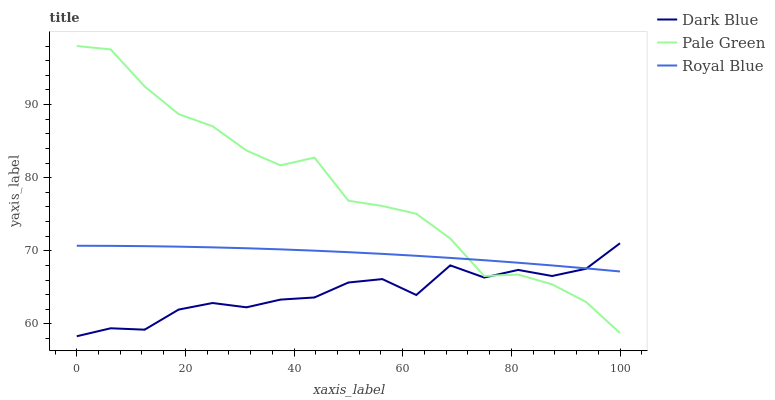Does Dark Blue have the minimum area under the curve?
Answer yes or no. Yes. Does Pale Green have the maximum area under the curve?
Answer yes or no. Yes. Does Royal Blue have the minimum area under the curve?
Answer yes or no. No. Does Royal Blue have the maximum area under the curve?
Answer yes or no. No. Is Royal Blue the smoothest?
Answer yes or no. Yes. Is Pale Green the roughest?
Answer yes or no. Yes. Is Pale Green the smoothest?
Answer yes or no. No. Is Royal Blue the roughest?
Answer yes or no. No. Does Dark Blue have the lowest value?
Answer yes or no. Yes. Does Pale Green have the lowest value?
Answer yes or no. No. Does Pale Green have the highest value?
Answer yes or no. Yes. Does Royal Blue have the highest value?
Answer yes or no. No. Does Royal Blue intersect Pale Green?
Answer yes or no. Yes. Is Royal Blue less than Pale Green?
Answer yes or no. No. Is Royal Blue greater than Pale Green?
Answer yes or no. No. 